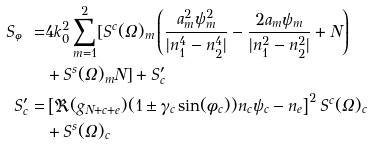<formula> <loc_0><loc_0><loc_500><loc_500>S _ { \varphi } = & 4 k _ { 0 } ^ { 2 } \sum _ { m = 1 } ^ { 2 } [ S ^ { c } ( \Omega ) _ { m } \left ( \frac { a _ { m } ^ { 2 } \psi _ { m } ^ { 2 } } { | n _ { 1 } ^ { 4 } - n _ { 2 } ^ { 4 } | } - \frac { 2 a _ { m } \psi _ { m } } { | n _ { 1 } ^ { 2 } - n _ { 2 } ^ { 2 } | } + N \right ) \\ & + S ^ { s } ( \Omega ) _ { m } N ] + S ^ { \prime } _ { c } \\ S ^ { \prime } _ { c } = & \left [ \Re ( g _ { N + c + e } ) ( 1 \pm \gamma _ { c } \sin ( \phi _ { c } ) ) n _ { c } \psi _ { c } - n _ { e } \right ] ^ { 2 } S ^ { c } ( \Omega ) _ { c } \\ & + S ^ { s } ( \Omega ) _ { c }</formula> 